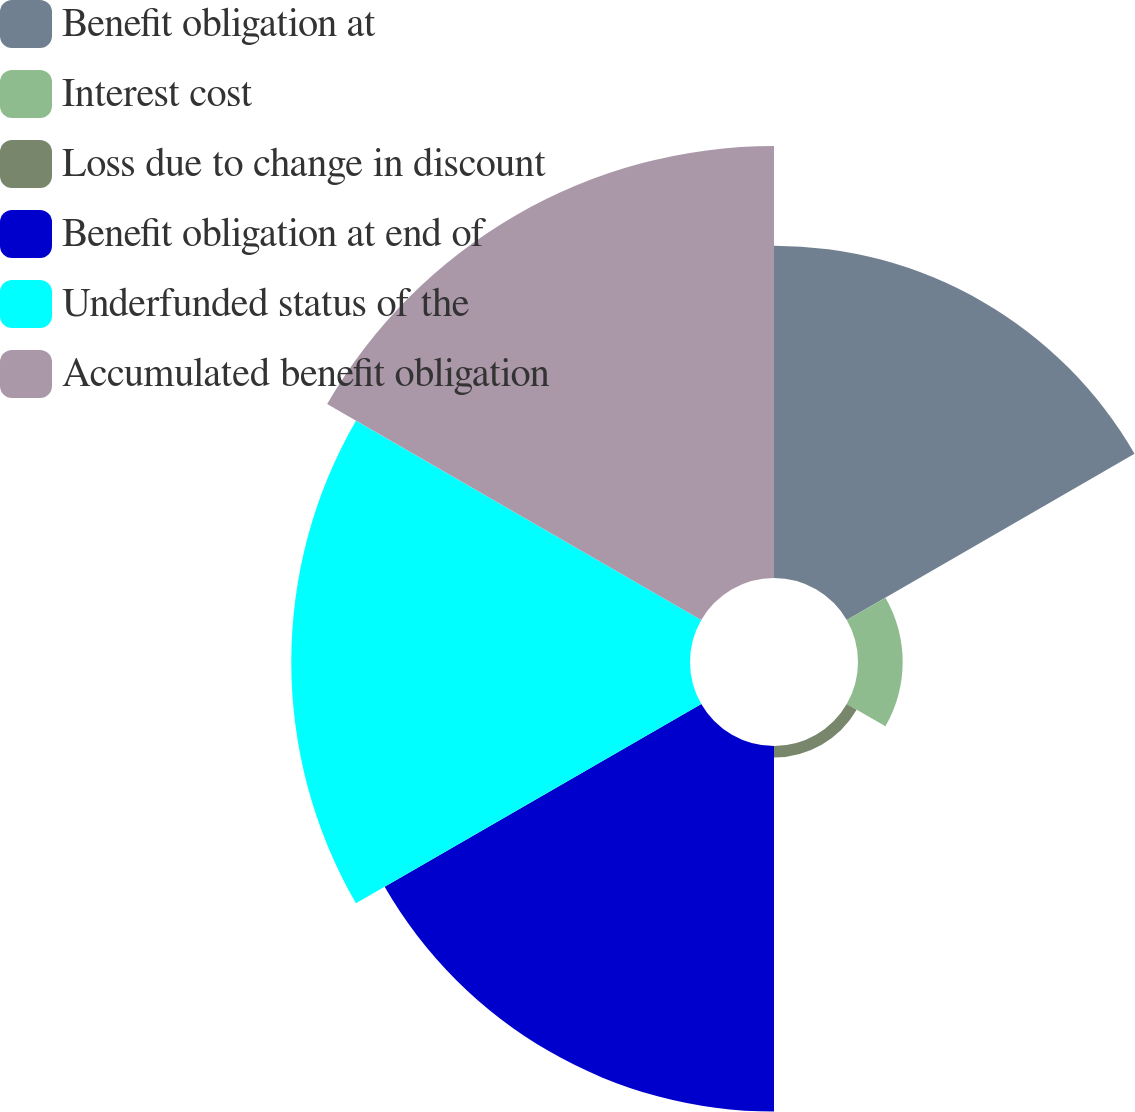Convert chart to OTSL. <chart><loc_0><loc_0><loc_500><loc_500><pie_chart><fcel>Benefit obligation at<fcel>Interest cost<fcel>Loss due to change in discount<fcel>Benefit obligation at end of<fcel>Underfunded status of the<fcel>Accumulated benefit obligation<nl><fcel>20.97%<fcel>2.82%<fcel>0.72%<fcel>23.07%<fcel>25.16%<fcel>27.26%<nl></chart> 